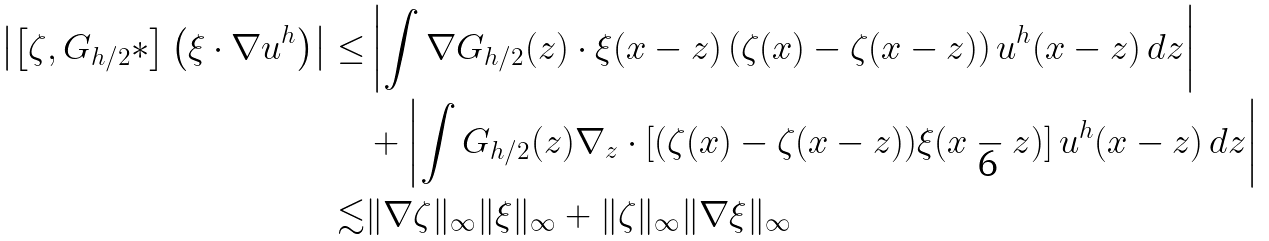<formula> <loc_0><loc_0><loc_500><loc_500>\left | \left [ \zeta , G _ { h / 2 } \ast \right ] \left ( \xi \cdot \nabla u ^ { h } \right ) \right | \leq & \left | \int \nabla G _ { h / 2 } ( z ) \cdot \xi ( x - z ) \left ( \zeta ( x ) - \zeta ( x - z ) \right ) u ^ { h } ( x - z ) \, d z \right | \\ & + \left | \int G _ { h / 2 } ( z ) \nabla _ { z } \cdot \left [ ( \zeta ( x ) - \zeta ( x - z ) ) \xi ( x - z ) \right ] u ^ { h } ( x - z ) \, d z \right | \\ \lesssim & \| \nabla \zeta \| _ { \infty } \| \xi \| _ { \infty } + \| \zeta \| _ { \infty } \| \nabla \xi \| _ { \infty }</formula> 